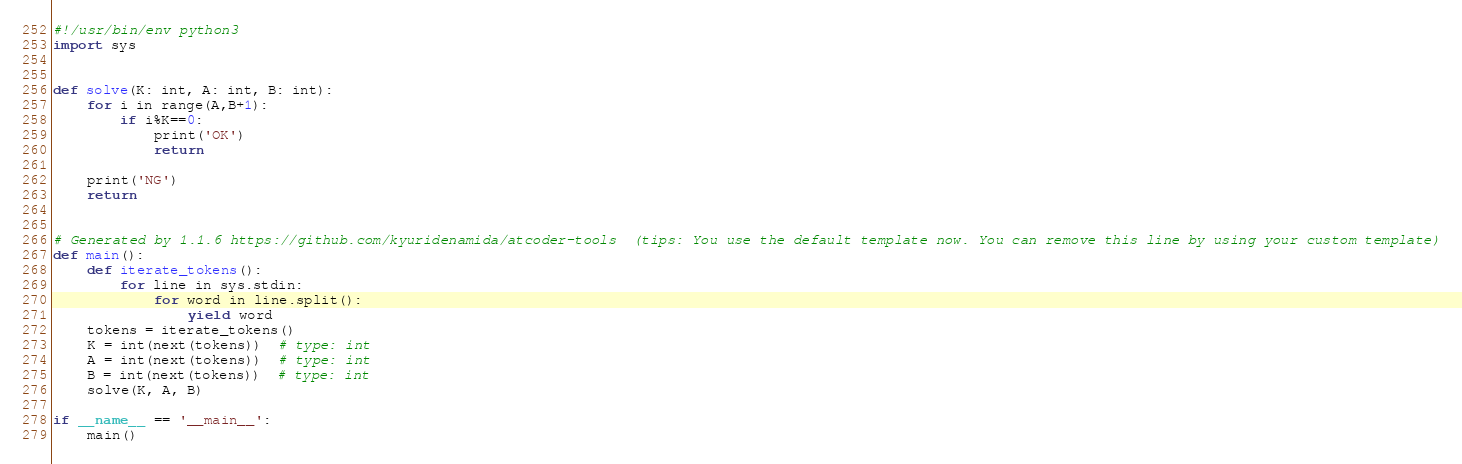Convert code to text. <code><loc_0><loc_0><loc_500><loc_500><_Python_>#!/usr/bin/env python3
import sys


def solve(K: int, A: int, B: int):
    for i in range(A,B+1):
        if i%K==0:
            print('OK')
            return
    
    print('NG')
    return


# Generated by 1.1.6 https://github.com/kyuridenamida/atcoder-tools  (tips: You use the default template now. You can remove this line by using your custom template)
def main():
    def iterate_tokens():
        for line in sys.stdin:
            for word in line.split():
                yield word
    tokens = iterate_tokens()
    K = int(next(tokens))  # type: int
    A = int(next(tokens))  # type: int
    B = int(next(tokens))  # type: int
    solve(K, A, B)

if __name__ == '__main__':
    main()
</code> 